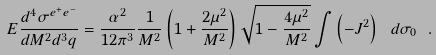<formula> <loc_0><loc_0><loc_500><loc_500>E \frac { d ^ { 4 } \sigma ^ { e ^ { + } e ^ { - } } } { d M ^ { 2 } d ^ { 3 } q } = \frac { \alpha ^ { 2 } } { 1 2 \pi ^ { 3 } } \frac { 1 } { M ^ { 2 } } \left ( 1 + \frac { 2 \mu ^ { 2 } } { M ^ { 2 } } \right ) \sqrt { 1 - \frac { 4 \mu ^ { 2 } } { M ^ { 2 } } } \int \left ( - J ^ { 2 } \right ) \ d \sigma _ { 0 } \ .</formula> 